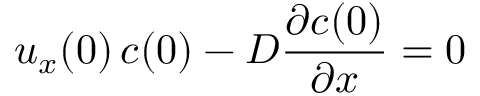Convert formula to latex. <formula><loc_0><loc_0><loc_500><loc_500>u _ { x } ( 0 ) \, c ( 0 ) - D { \frac { \partial c ( 0 ) } { \partial x } } = 0</formula> 